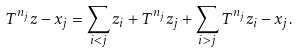<formula> <loc_0><loc_0><loc_500><loc_500>T ^ { n _ { j } } z - x _ { j } & = \sum _ { i < j } z _ { i } + T ^ { n _ { j } } z _ { j } + \sum _ { i > j } T ^ { n _ { j } } z _ { i } - x _ { j } .</formula> 